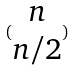Convert formula to latex. <formula><loc_0><loc_0><loc_500><loc_500>( \begin{matrix} n \\ n / 2 \end{matrix} )</formula> 